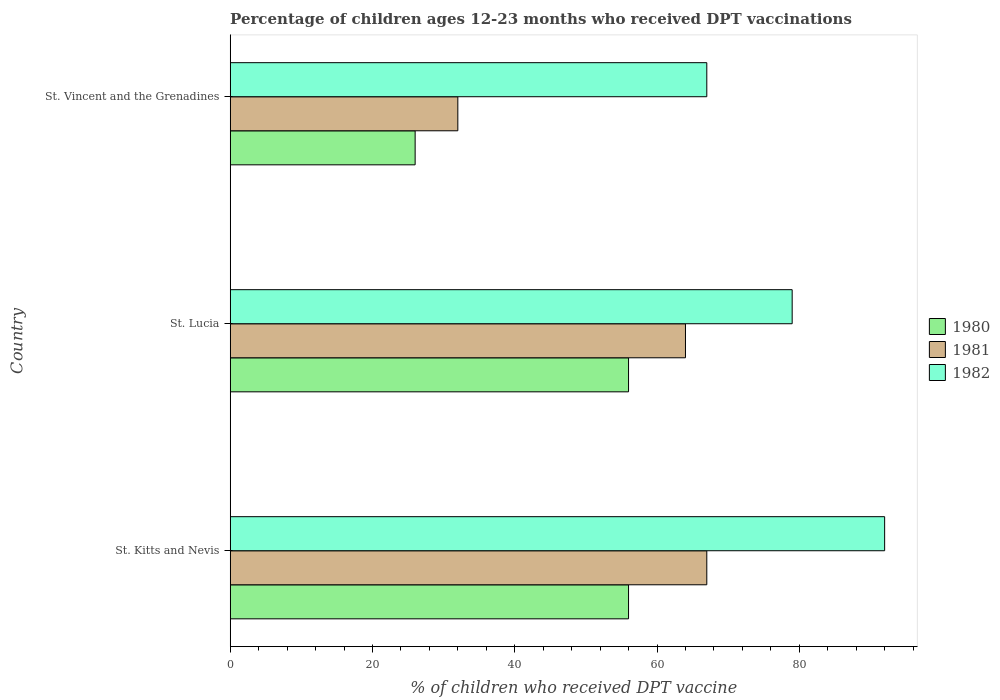How many different coloured bars are there?
Keep it short and to the point. 3. Are the number of bars per tick equal to the number of legend labels?
Keep it short and to the point. Yes. What is the label of the 2nd group of bars from the top?
Your answer should be very brief. St. Lucia. Across all countries, what is the maximum percentage of children who received DPT vaccination in 1980?
Ensure brevity in your answer.  56. In which country was the percentage of children who received DPT vaccination in 1982 maximum?
Your answer should be compact. St. Kitts and Nevis. In which country was the percentage of children who received DPT vaccination in 1980 minimum?
Give a very brief answer. St. Vincent and the Grenadines. What is the total percentage of children who received DPT vaccination in 1980 in the graph?
Give a very brief answer. 138. What is the difference between the percentage of children who received DPT vaccination in 1980 in St. Lucia and that in St. Vincent and the Grenadines?
Ensure brevity in your answer.  30. What is the difference between the percentage of children who received DPT vaccination in 1980 in St. Vincent and the Grenadines and the percentage of children who received DPT vaccination in 1982 in St. Kitts and Nevis?
Your response must be concise. -66. What is the average percentage of children who received DPT vaccination in 1982 per country?
Make the answer very short. 79.33. What is the ratio of the percentage of children who received DPT vaccination in 1980 in St. Kitts and Nevis to that in St. Lucia?
Your answer should be very brief. 1. Is the difference between the percentage of children who received DPT vaccination in 1980 in St. Kitts and Nevis and St. Lucia greater than the difference between the percentage of children who received DPT vaccination in 1982 in St. Kitts and Nevis and St. Lucia?
Give a very brief answer. No. What does the 2nd bar from the top in St. Kitts and Nevis represents?
Ensure brevity in your answer.  1981. Is it the case that in every country, the sum of the percentage of children who received DPT vaccination in 1982 and percentage of children who received DPT vaccination in 1980 is greater than the percentage of children who received DPT vaccination in 1981?
Give a very brief answer. Yes. How many bars are there?
Offer a terse response. 9. Are all the bars in the graph horizontal?
Your answer should be very brief. Yes. How many countries are there in the graph?
Offer a terse response. 3. What is the difference between two consecutive major ticks on the X-axis?
Offer a terse response. 20. Are the values on the major ticks of X-axis written in scientific E-notation?
Ensure brevity in your answer.  No. How many legend labels are there?
Offer a very short reply. 3. What is the title of the graph?
Provide a short and direct response. Percentage of children ages 12-23 months who received DPT vaccinations. What is the label or title of the X-axis?
Make the answer very short. % of children who received DPT vaccine. What is the label or title of the Y-axis?
Offer a very short reply. Country. What is the % of children who received DPT vaccine of 1980 in St. Kitts and Nevis?
Your response must be concise. 56. What is the % of children who received DPT vaccine in 1982 in St. Kitts and Nevis?
Keep it short and to the point. 92. What is the % of children who received DPT vaccine in 1980 in St. Lucia?
Give a very brief answer. 56. What is the % of children who received DPT vaccine of 1981 in St. Lucia?
Provide a succinct answer. 64. What is the % of children who received DPT vaccine in 1982 in St. Lucia?
Your answer should be compact. 79. Across all countries, what is the maximum % of children who received DPT vaccine in 1982?
Ensure brevity in your answer.  92. Across all countries, what is the minimum % of children who received DPT vaccine of 1980?
Your answer should be compact. 26. Across all countries, what is the minimum % of children who received DPT vaccine of 1982?
Your answer should be very brief. 67. What is the total % of children who received DPT vaccine in 1980 in the graph?
Make the answer very short. 138. What is the total % of children who received DPT vaccine of 1981 in the graph?
Provide a short and direct response. 163. What is the total % of children who received DPT vaccine in 1982 in the graph?
Make the answer very short. 238. What is the difference between the % of children who received DPT vaccine in 1981 in St. Kitts and Nevis and that in St. Lucia?
Keep it short and to the point. 3. What is the difference between the % of children who received DPT vaccine in 1982 in St. Kitts and Nevis and that in St. Lucia?
Provide a short and direct response. 13. What is the difference between the % of children who received DPT vaccine of 1980 in St. Kitts and Nevis and that in St. Vincent and the Grenadines?
Your answer should be very brief. 30. What is the difference between the % of children who received DPT vaccine of 1982 in St. Kitts and Nevis and that in St. Vincent and the Grenadines?
Ensure brevity in your answer.  25. What is the difference between the % of children who received DPT vaccine of 1980 in St. Lucia and that in St. Vincent and the Grenadines?
Provide a short and direct response. 30. What is the difference between the % of children who received DPT vaccine in 1981 in St. Lucia and that in St. Vincent and the Grenadines?
Offer a terse response. 32. What is the difference between the % of children who received DPT vaccine of 1982 in St. Lucia and that in St. Vincent and the Grenadines?
Provide a succinct answer. 12. What is the difference between the % of children who received DPT vaccine of 1980 in St. Kitts and Nevis and the % of children who received DPT vaccine of 1982 in St. Lucia?
Your answer should be compact. -23. What is the difference between the % of children who received DPT vaccine in 1980 in St. Kitts and Nevis and the % of children who received DPT vaccine in 1982 in St. Vincent and the Grenadines?
Offer a very short reply. -11. What is the difference between the % of children who received DPT vaccine of 1980 in St. Lucia and the % of children who received DPT vaccine of 1982 in St. Vincent and the Grenadines?
Ensure brevity in your answer.  -11. What is the average % of children who received DPT vaccine in 1980 per country?
Provide a succinct answer. 46. What is the average % of children who received DPT vaccine in 1981 per country?
Provide a succinct answer. 54.33. What is the average % of children who received DPT vaccine of 1982 per country?
Your answer should be compact. 79.33. What is the difference between the % of children who received DPT vaccine in 1980 and % of children who received DPT vaccine in 1981 in St. Kitts and Nevis?
Keep it short and to the point. -11. What is the difference between the % of children who received DPT vaccine of 1980 and % of children who received DPT vaccine of 1982 in St. Kitts and Nevis?
Ensure brevity in your answer.  -36. What is the difference between the % of children who received DPT vaccine of 1980 and % of children who received DPT vaccine of 1982 in St. Lucia?
Your answer should be very brief. -23. What is the difference between the % of children who received DPT vaccine in 1981 and % of children who received DPT vaccine in 1982 in St. Lucia?
Your answer should be compact. -15. What is the difference between the % of children who received DPT vaccine in 1980 and % of children who received DPT vaccine in 1981 in St. Vincent and the Grenadines?
Offer a terse response. -6. What is the difference between the % of children who received DPT vaccine in 1980 and % of children who received DPT vaccine in 1982 in St. Vincent and the Grenadines?
Keep it short and to the point. -41. What is the difference between the % of children who received DPT vaccine in 1981 and % of children who received DPT vaccine in 1982 in St. Vincent and the Grenadines?
Keep it short and to the point. -35. What is the ratio of the % of children who received DPT vaccine in 1981 in St. Kitts and Nevis to that in St. Lucia?
Your answer should be compact. 1.05. What is the ratio of the % of children who received DPT vaccine of 1982 in St. Kitts and Nevis to that in St. Lucia?
Offer a very short reply. 1.16. What is the ratio of the % of children who received DPT vaccine in 1980 in St. Kitts and Nevis to that in St. Vincent and the Grenadines?
Give a very brief answer. 2.15. What is the ratio of the % of children who received DPT vaccine in 1981 in St. Kitts and Nevis to that in St. Vincent and the Grenadines?
Offer a terse response. 2.09. What is the ratio of the % of children who received DPT vaccine in 1982 in St. Kitts and Nevis to that in St. Vincent and the Grenadines?
Keep it short and to the point. 1.37. What is the ratio of the % of children who received DPT vaccine of 1980 in St. Lucia to that in St. Vincent and the Grenadines?
Offer a terse response. 2.15. What is the ratio of the % of children who received DPT vaccine in 1982 in St. Lucia to that in St. Vincent and the Grenadines?
Provide a short and direct response. 1.18. What is the difference between the highest and the second highest % of children who received DPT vaccine in 1981?
Your answer should be very brief. 3. What is the difference between the highest and the second highest % of children who received DPT vaccine in 1982?
Your response must be concise. 13. What is the difference between the highest and the lowest % of children who received DPT vaccine in 1981?
Ensure brevity in your answer.  35. What is the difference between the highest and the lowest % of children who received DPT vaccine in 1982?
Make the answer very short. 25. 